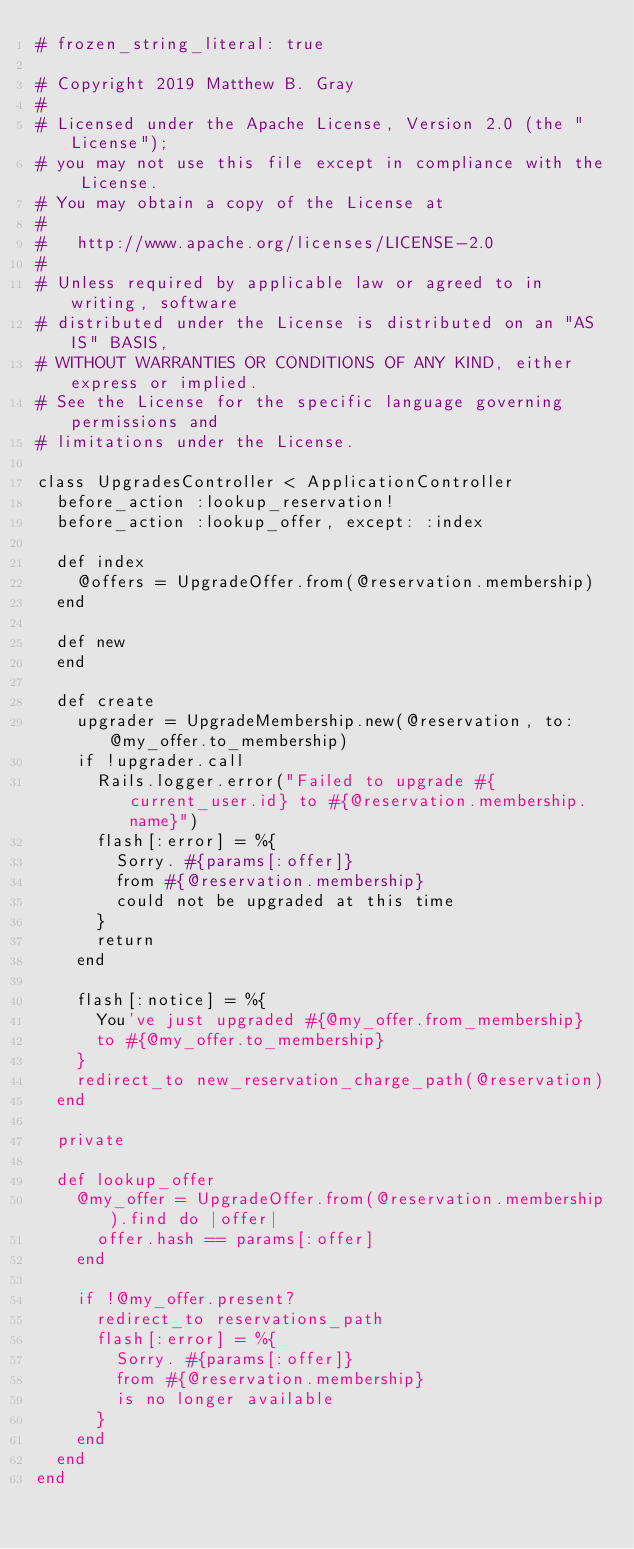Convert code to text. <code><loc_0><loc_0><loc_500><loc_500><_Ruby_># frozen_string_literal: true

# Copyright 2019 Matthew B. Gray
#
# Licensed under the Apache License, Version 2.0 (the "License");
# you may not use this file except in compliance with the License.
# You may obtain a copy of the License at
#
#   http://www.apache.org/licenses/LICENSE-2.0
#
# Unless required by applicable law or agreed to in writing, software
# distributed under the License is distributed on an "AS IS" BASIS,
# WITHOUT WARRANTIES OR CONDITIONS OF ANY KIND, either express or implied.
# See the License for the specific language governing permissions and
# limitations under the License.

class UpgradesController < ApplicationController
  before_action :lookup_reservation!
  before_action :lookup_offer, except: :index

  def index
    @offers = UpgradeOffer.from(@reservation.membership)
  end

  def new
  end

  def create
    upgrader = UpgradeMembership.new(@reservation, to: @my_offer.to_membership)
    if !upgrader.call
      Rails.logger.error("Failed to upgrade #{current_user.id} to #{@reservation.membership.name}")
      flash[:error] = %{
        Sorry. #{params[:offer]}
        from #{@reservation.membership}
        could not be upgraded at this time
      }
      return
    end

    flash[:notice] = %{
      You've just upgraded #{@my_offer.from_membership}
      to #{@my_offer.to_membership}
    }
    redirect_to new_reservation_charge_path(@reservation)
  end

  private

  def lookup_offer
    @my_offer = UpgradeOffer.from(@reservation.membership).find do |offer|
      offer.hash == params[:offer]
    end

    if !@my_offer.present?
      redirect_to reservations_path
      flash[:error] = %{
        Sorry. #{params[:offer]}
        from #{@reservation.membership}
        is no longer available
      }
    end
  end
end
</code> 